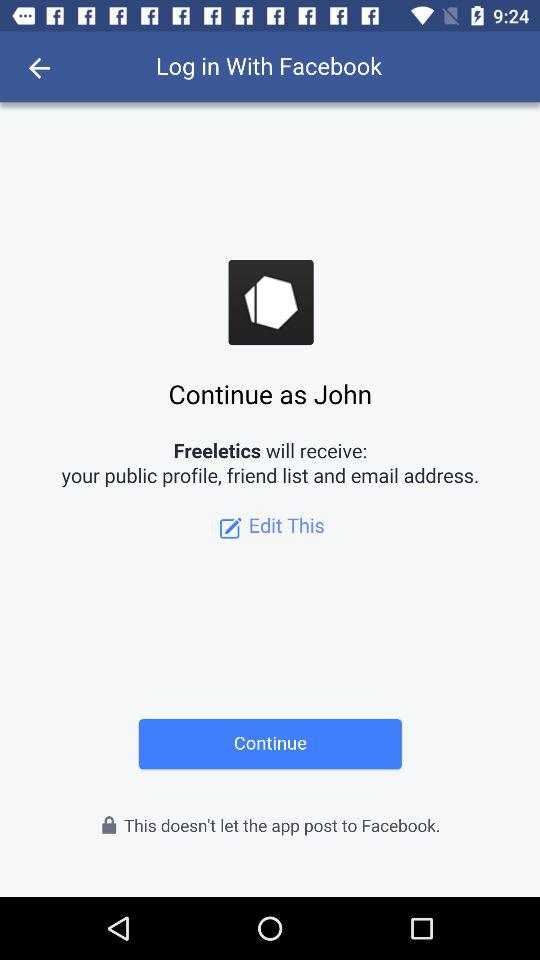What is the user name to continue on the login page? The user name is John. 